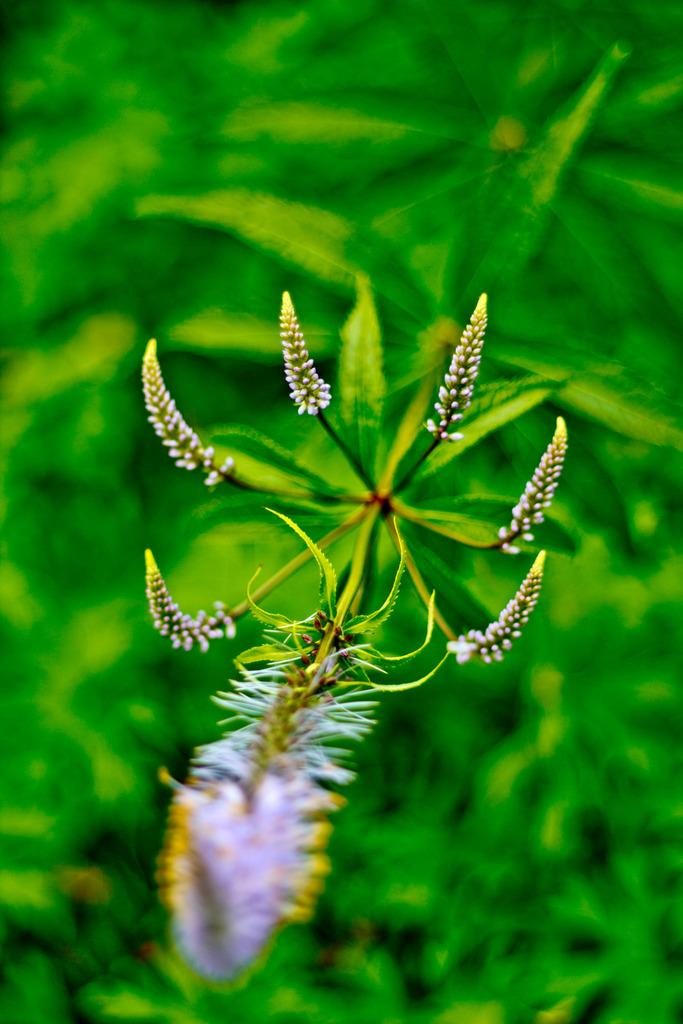What types of living organisms can be seen in the image? Plants and flowers are visible in the image. Can you describe the flowers in the image? The flowers in the image are colorful and appear to be in bloom. What type of agreement was reached by the goldfish in the image? There are no goldfish present in the image, so no agreement can be reached by them. 